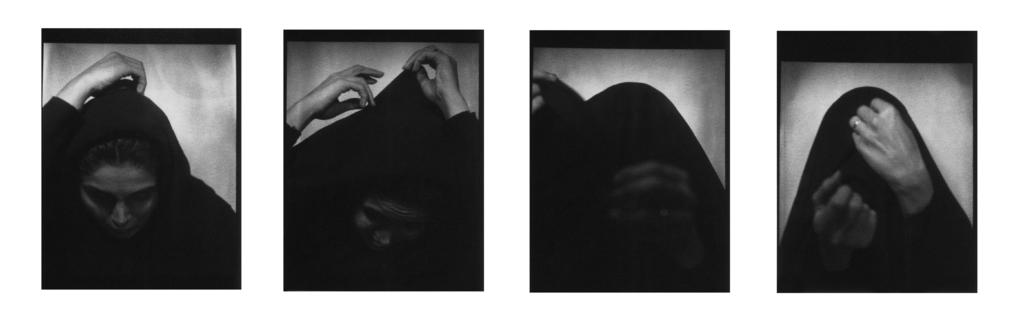What is depicted in the image? There is a picture of a colleague in the image. Can you describe the person in the picture? The person in the picture is the same person as in another image. What is the person in the picture wearing? The person in the picture is wearing a black color jacket. What type of bone can be seen in the picture? There is no bone present in the image; it features a picture of a colleague. What territory does the person in the picture claim as their own? The image does not provide any information about territorial claims or boundaries. 